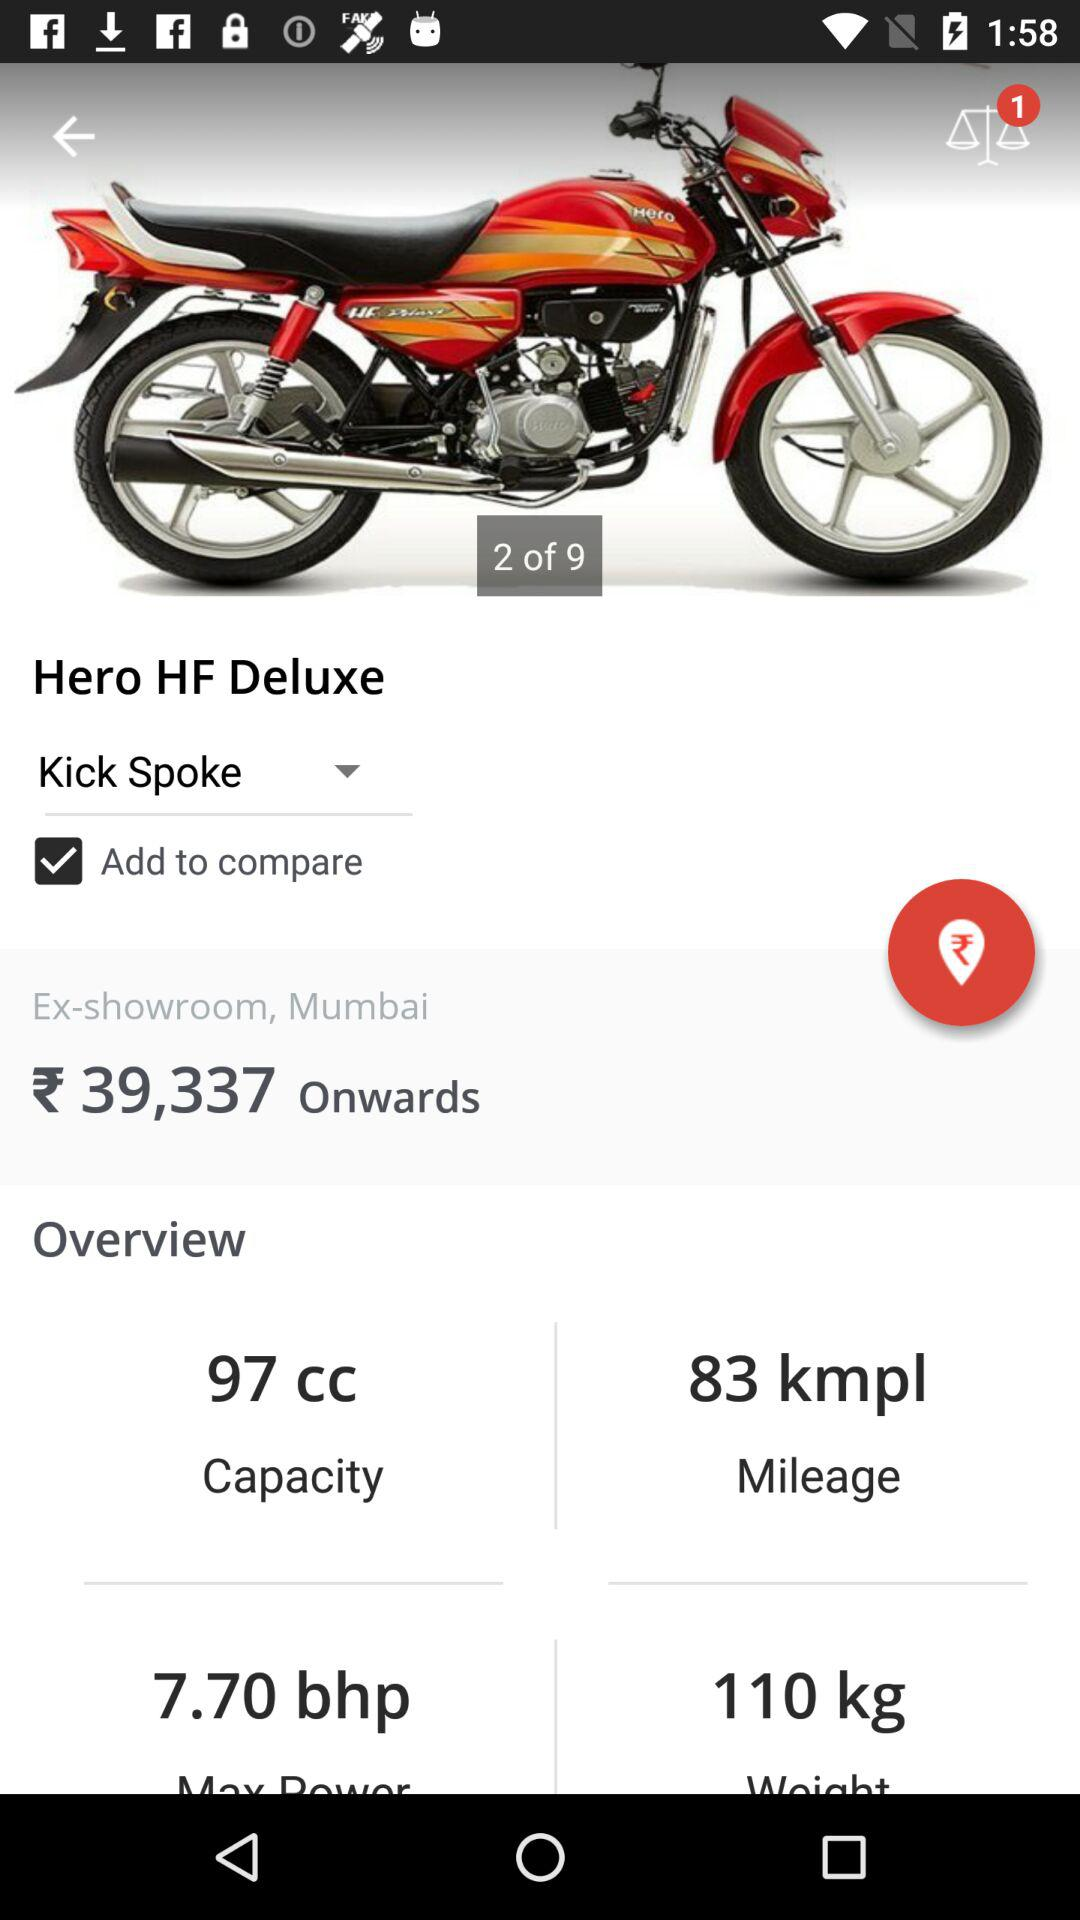What is the mileage of the bike? The mileage of the bike is 83 kmpl. 